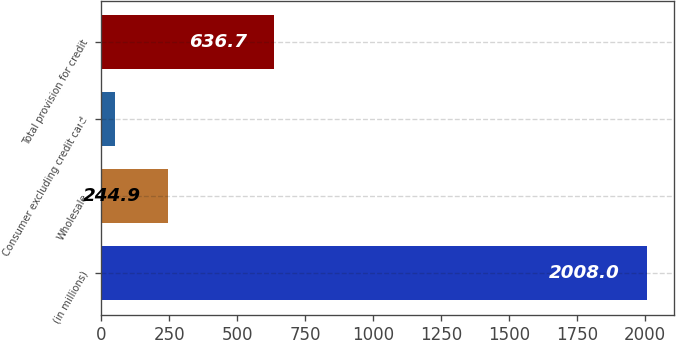Convert chart. <chart><loc_0><loc_0><loc_500><loc_500><bar_chart><fcel>(in millions)<fcel>Wholesale<fcel>Consumer excluding credit card<fcel>Total provision for credit<nl><fcel>2008<fcel>244.9<fcel>49<fcel>636.7<nl></chart> 